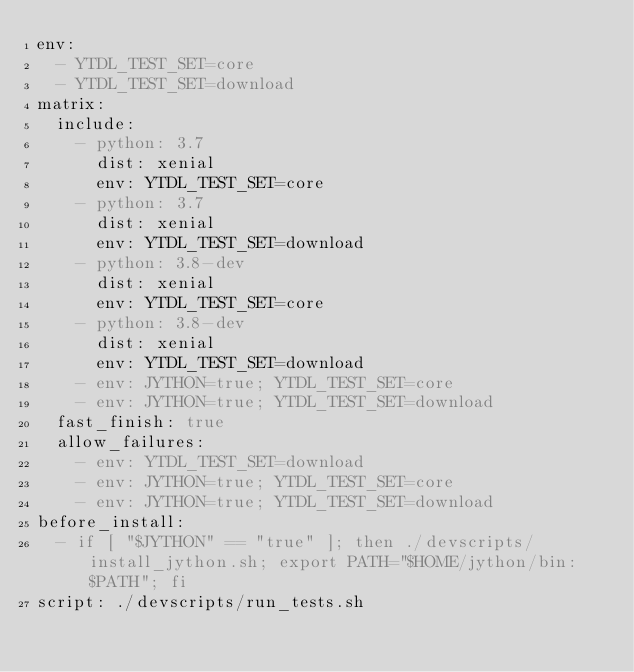<code> <loc_0><loc_0><loc_500><loc_500><_YAML_>env:
  - YTDL_TEST_SET=core
  - YTDL_TEST_SET=download
matrix:
  include:
    - python: 3.7
      dist: xenial
      env: YTDL_TEST_SET=core
    - python: 3.7
      dist: xenial
      env: YTDL_TEST_SET=download
    - python: 3.8-dev
      dist: xenial
      env: YTDL_TEST_SET=core
    - python: 3.8-dev
      dist: xenial
      env: YTDL_TEST_SET=download
    - env: JYTHON=true; YTDL_TEST_SET=core
    - env: JYTHON=true; YTDL_TEST_SET=download
  fast_finish: true
  allow_failures:
    - env: YTDL_TEST_SET=download
    - env: JYTHON=true; YTDL_TEST_SET=core
    - env: JYTHON=true; YTDL_TEST_SET=download
before_install:
  - if [ "$JYTHON" == "true" ]; then ./devscripts/install_jython.sh; export PATH="$HOME/jython/bin:$PATH"; fi
script: ./devscripts/run_tests.sh
</code> 